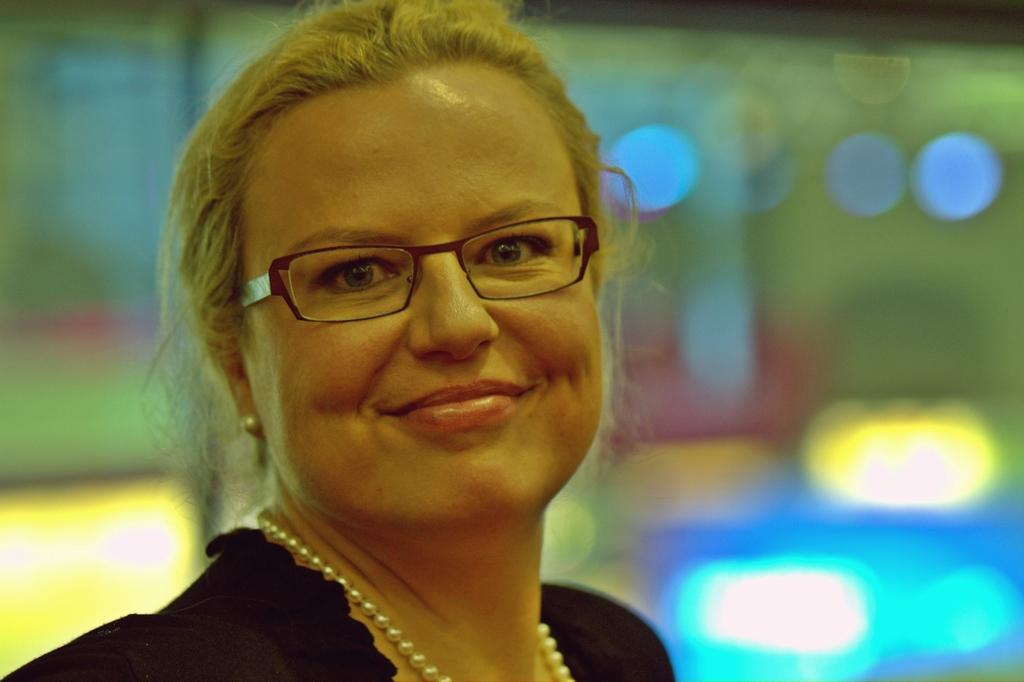What is the main subject of the image? There is a person in the image. What is the person wearing? The person is wearing a black dress and specs. Can you describe the background of the image? The background of the image is blurred. What type of produce is the person holding in the image? There is no produce present in the image; the person is not holding anything. What does the person desire in the image? The image does not provide any information about the person's desires or emotions. 